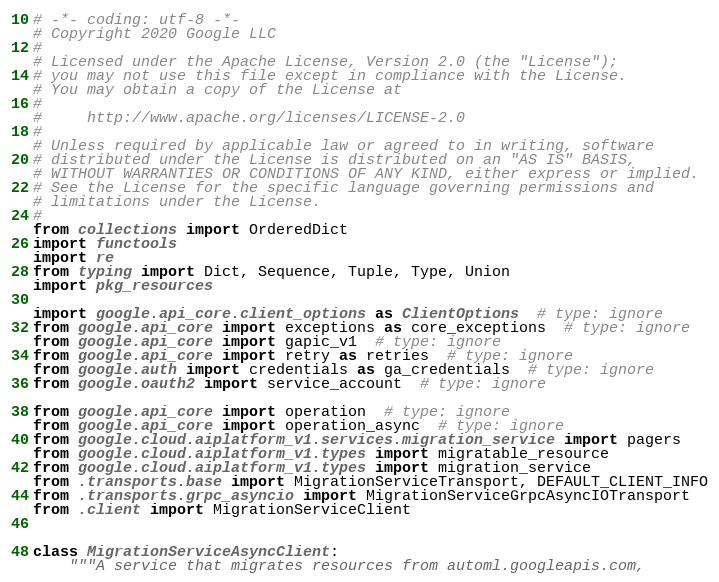<code> <loc_0><loc_0><loc_500><loc_500><_Python_># -*- coding: utf-8 -*-
# Copyright 2020 Google LLC
#
# Licensed under the Apache License, Version 2.0 (the "License");
# you may not use this file except in compliance with the License.
# You may obtain a copy of the License at
#
#     http://www.apache.org/licenses/LICENSE-2.0
#
# Unless required by applicable law or agreed to in writing, software
# distributed under the License is distributed on an "AS IS" BASIS,
# WITHOUT WARRANTIES OR CONDITIONS OF ANY KIND, either express or implied.
# See the License for the specific language governing permissions and
# limitations under the License.
#
from collections import OrderedDict
import functools
import re
from typing import Dict, Sequence, Tuple, Type, Union
import pkg_resources

import google.api_core.client_options as ClientOptions  # type: ignore
from google.api_core import exceptions as core_exceptions  # type: ignore
from google.api_core import gapic_v1  # type: ignore
from google.api_core import retry as retries  # type: ignore
from google.auth import credentials as ga_credentials  # type: ignore
from google.oauth2 import service_account  # type: ignore

from google.api_core import operation  # type: ignore
from google.api_core import operation_async  # type: ignore
from google.cloud.aiplatform_v1.services.migration_service import pagers
from google.cloud.aiplatform_v1.types import migratable_resource
from google.cloud.aiplatform_v1.types import migration_service
from .transports.base import MigrationServiceTransport, DEFAULT_CLIENT_INFO
from .transports.grpc_asyncio import MigrationServiceGrpcAsyncIOTransport
from .client import MigrationServiceClient


class MigrationServiceAsyncClient:
    """A service that migrates resources from automl.googleapis.com,</code> 